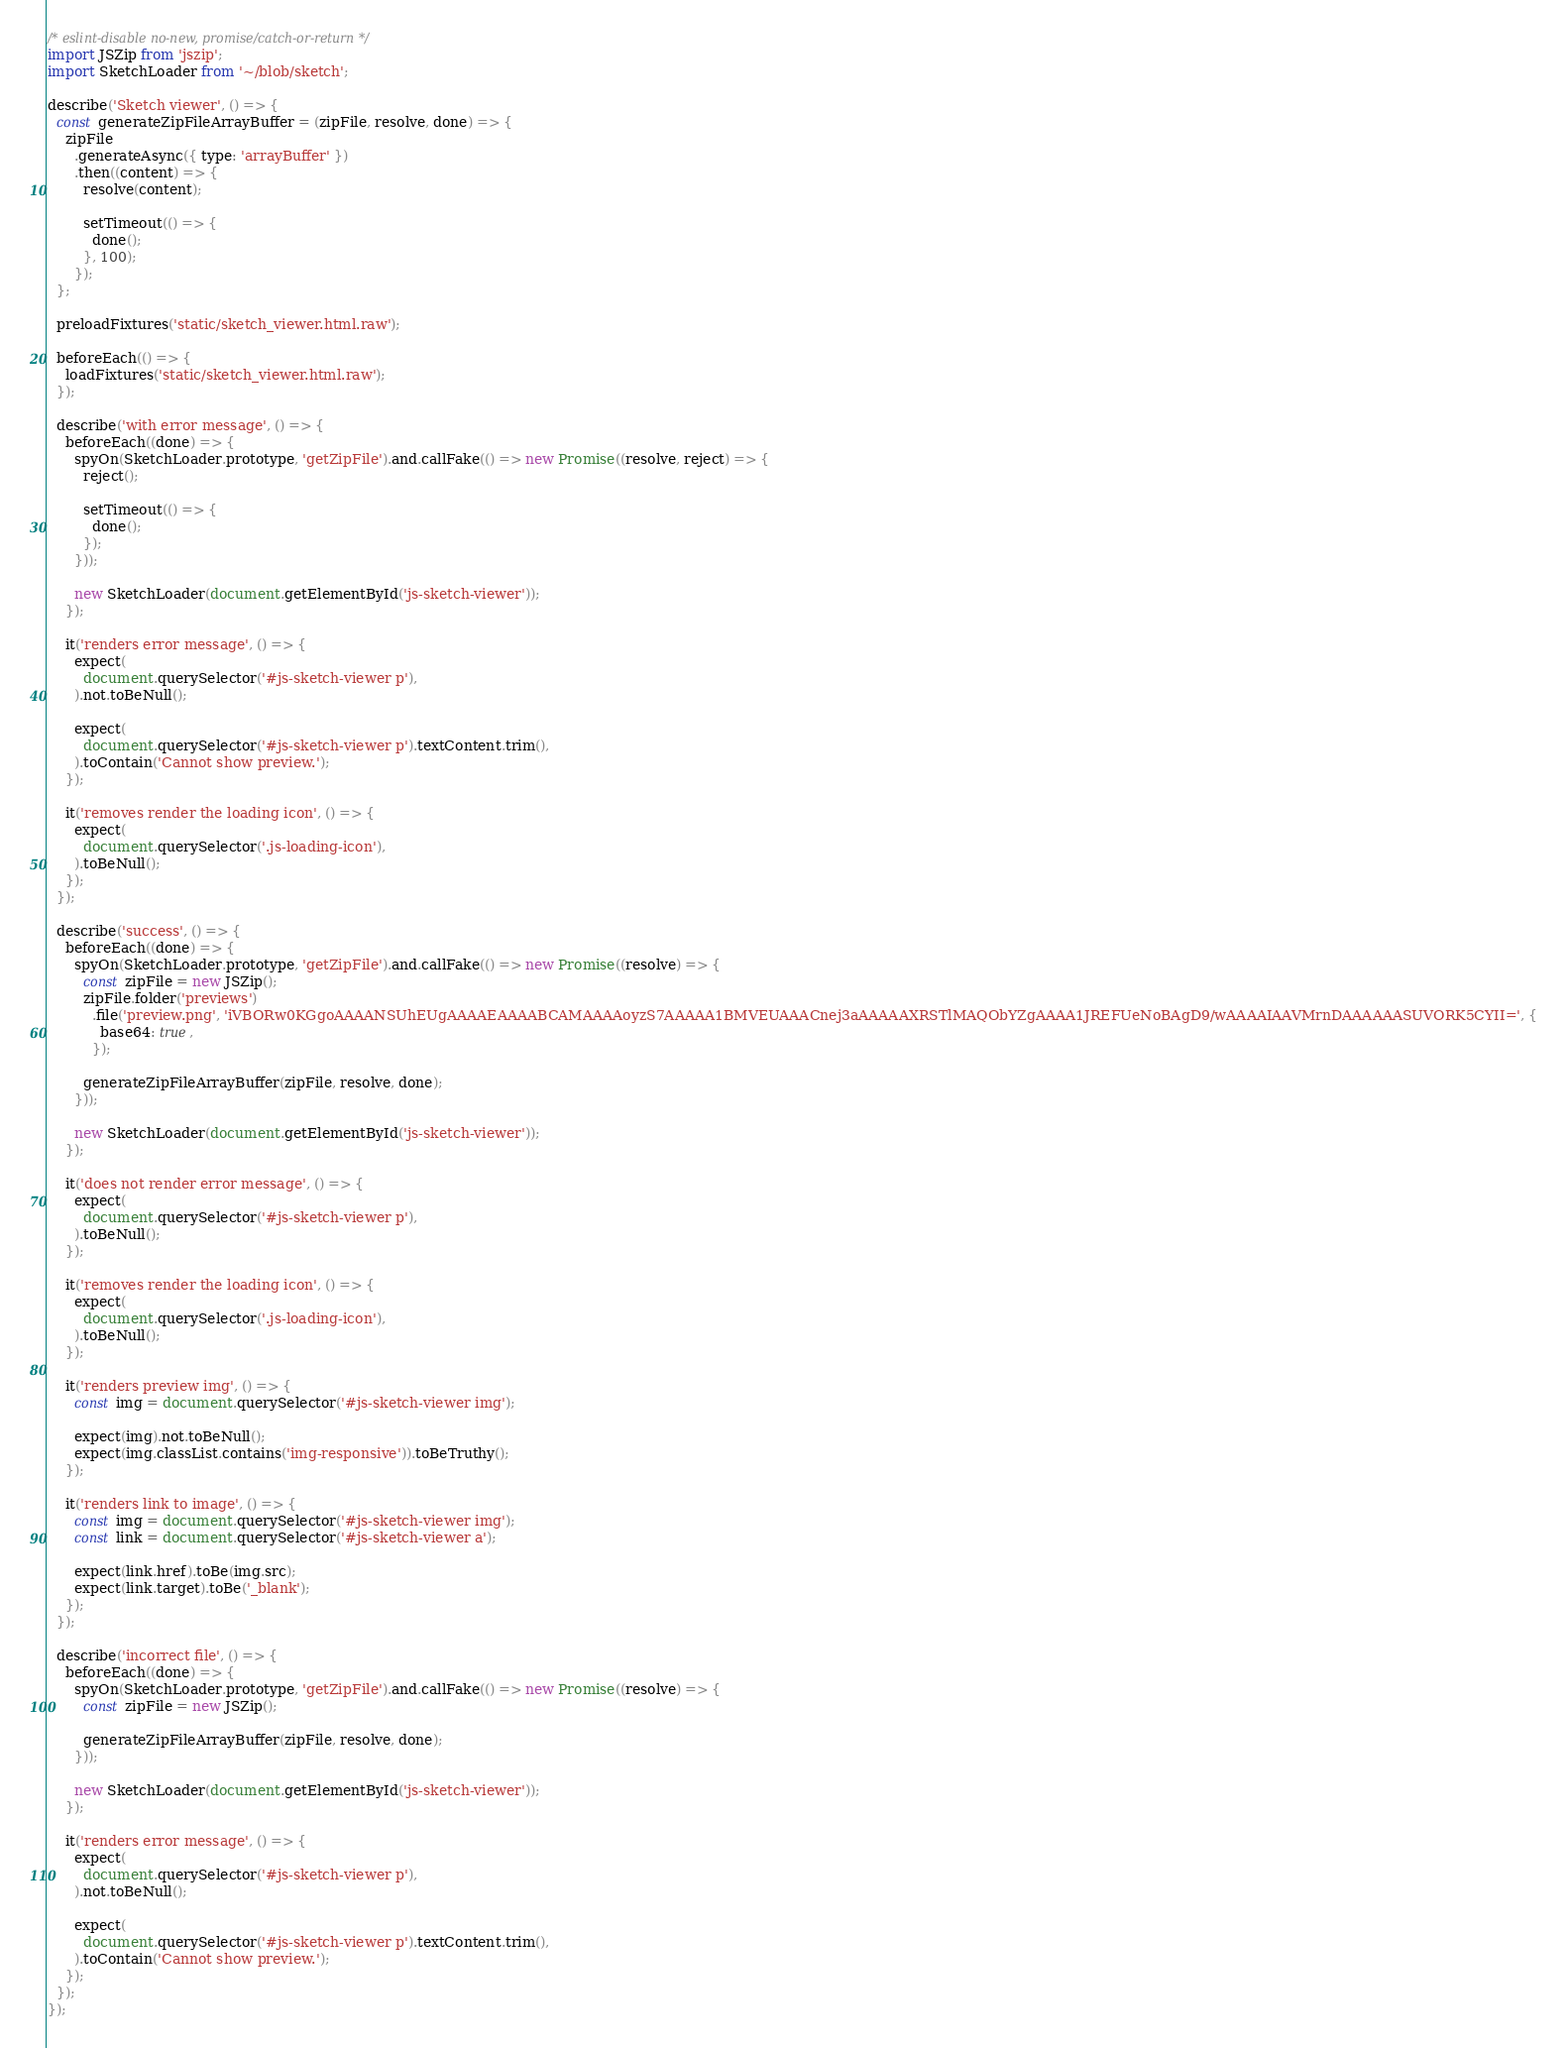Convert code to text. <code><loc_0><loc_0><loc_500><loc_500><_JavaScript_>/* eslint-disable no-new, promise/catch-or-return */
import JSZip from 'jszip';
import SketchLoader from '~/blob/sketch';

describe('Sketch viewer', () => {
  const generateZipFileArrayBuffer = (zipFile, resolve, done) => {
    zipFile
      .generateAsync({ type: 'arrayBuffer' })
      .then((content) => {
        resolve(content);

        setTimeout(() => {
          done();
        }, 100);
      });
  };

  preloadFixtures('static/sketch_viewer.html.raw');

  beforeEach(() => {
    loadFixtures('static/sketch_viewer.html.raw');
  });

  describe('with error message', () => {
    beforeEach((done) => {
      spyOn(SketchLoader.prototype, 'getZipFile').and.callFake(() => new Promise((resolve, reject) => {
        reject();

        setTimeout(() => {
          done();
        });
      }));

      new SketchLoader(document.getElementById('js-sketch-viewer'));
    });

    it('renders error message', () => {
      expect(
        document.querySelector('#js-sketch-viewer p'),
      ).not.toBeNull();

      expect(
        document.querySelector('#js-sketch-viewer p').textContent.trim(),
      ).toContain('Cannot show preview.');
    });

    it('removes render the loading icon', () => {
      expect(
        document.querySelector('.js-loading-icon'),
      ).toBeNull();
    });
  });

  describe('success', () => {
    beforeEach((done) => {
      spyOn(SketchLoader.prototype, 'getZipFile').and.callFake(() => new Promise((resolve) => {
        const zipFile = new JSZip();
        zipFile.folder('previews')
          .file('preview.png', 'iVBORw0KGgoAAAANSUhEUgAAAAEAAAABCAMAAAAoyzS7AAAAA1BMVEUAAACnej3aAAAAAXRSTlMAQObYZgAAAA1JREFUeNoBAgD9/wAAAAIAAVMrnDAAAAAASUVORK5CYII=', {
            base64: true,
          });

        generateZipFileArrayBuffer(zipFile, resolve, done);
      }));

      new SketchLoader(document.getElementById('js-sketch-viewer'));
    });

    it('does not render error message', () => {
      expect(
        document.querySelector('#js-sketch-viewer p'),
      ).toBeNull();
    });

    it('removes render the loading icon', () => {
      expect(
        document.querySelector('.js-loading-icon'),
      ).toBeNull();
    });

    it('renders preview img', () => {
      const img = document.querySelector('#js-sketch-viewer img');

      expect(img).not.toBeNull();
      expect(img.classList.contains('img-responsive')).toBeTruthy();
    });

    it('renders link to image', () => {
      const img = document.querySelector('#js-sketch-viewer img');
      const link = document.querySelector('#js-sketch-viewer a');

      expect(link.href).toBe(img.src);
      expect(link.target).toBe('_blank');
    });
  });

  describe('incorrect file', () => {
    beforeEach((done) => {
      spyOn(SketchLoader.prototype, 'getZipFile').and.callFake(() => new Promise((resolve) => {
        const zipFile = new JSZip();

        generateZipFileArrayBuffer(zipFile, resolve, done);
      }));

      new SketchLoader(document.getElementById('js-sketch-viewer'));
    });

    it('renders error message', () => {
      expect(
        document.querySelector('#js-sketch-viewer p'),
      ).not.toBeNull();

      expect(
        document.querySelector('#js-sketch-viewer p').textContent.trim(),
      ).toContain('Cannot show preview.');
    });
  });
});
</code> 